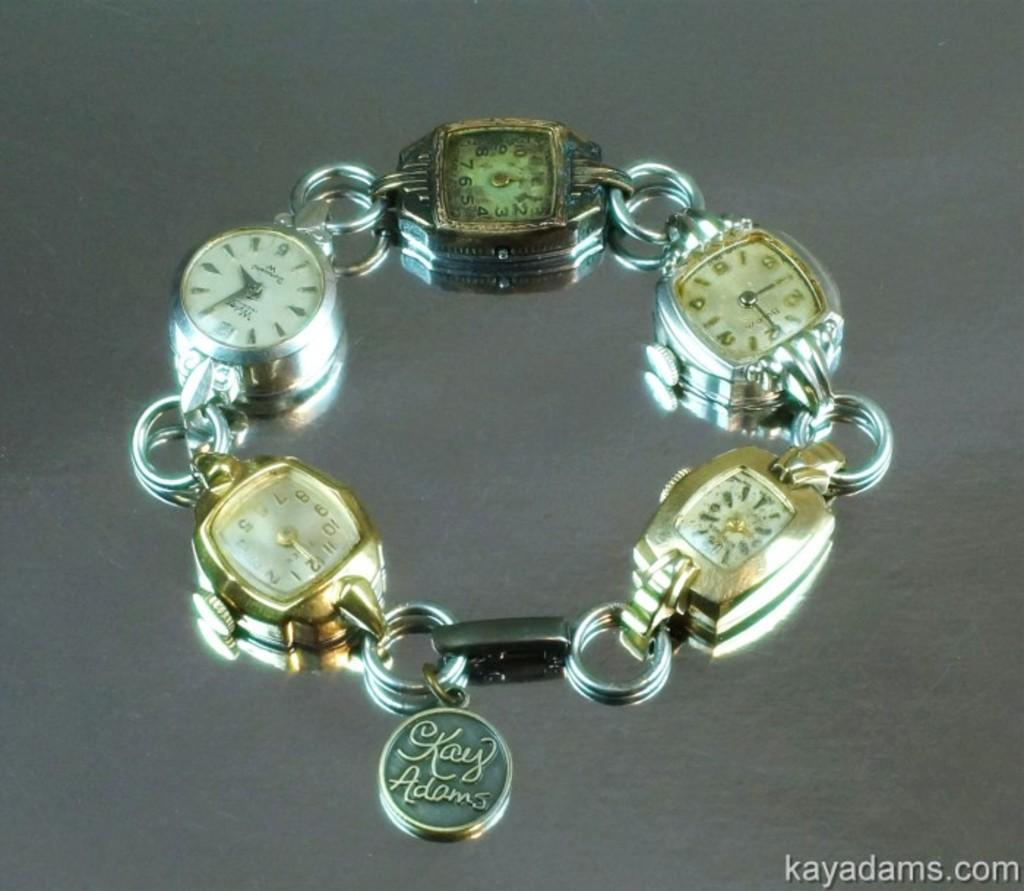<image>
Create a compact narrative representing the image presented. A small charm bracelet with clocks made by Kay Adams 